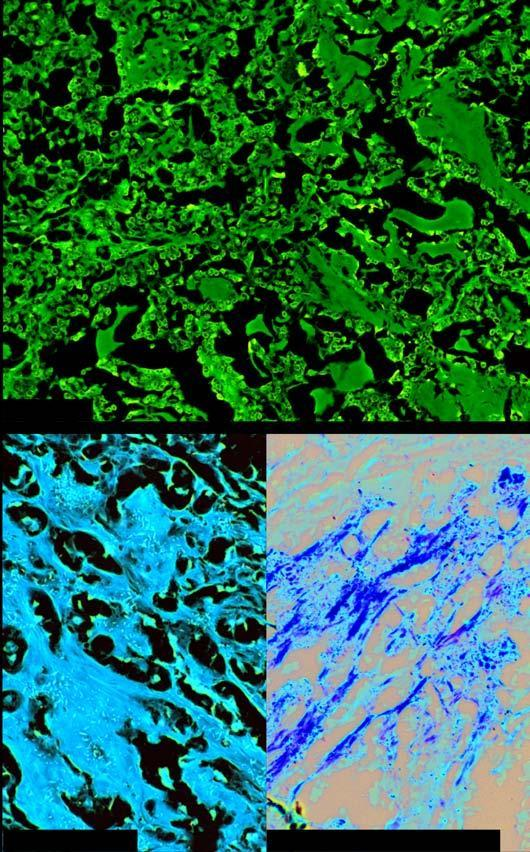what does microscopy show?
Answer the question using a single word or phrase. Organoid pattern of oval tumour cells and abundant amyloid stroma 